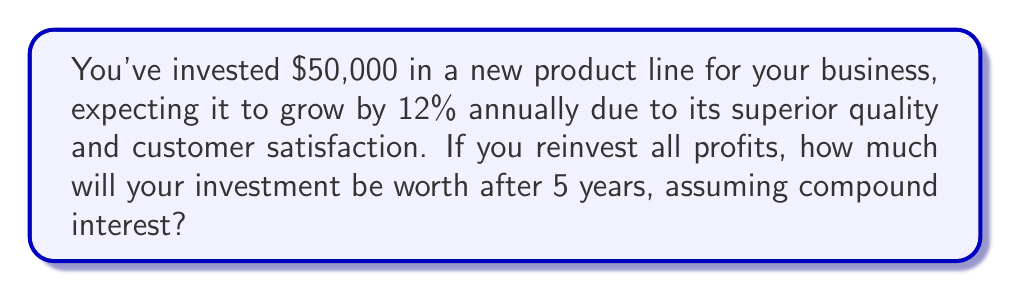Could you help me with this problem? To solve this problem, we'll use the compound interest formula:

$$ A = P(1 + r)^n $$

Where:
$A$ = Final amount
$P$ = Principal (initial investment)
$r$ = Annual interest rate (in decimal form)
$n$ = Number of years

Given:
$P = $50,000
$r = 12\% = 0.12
$n = 5$ years

Let's plug these values into the formula:

$$ A = 50,000(1 + 0.12)^5 $$

Now, let's calculate step-by-step:

1) First, calculate $(1 + 0.12)^5$:
   $$ (1.12)^5 = 1.762341968 $$

2) Multiply this result by the principal:
   $$ 50,000 \times 1.762341968 = 88,117.0984 $$

3) Round to the nearest cent:
   $$ 88,117.10 $$

Therefore, after 5 years, your $50,000 investment will grow to $88,117.10.
Answer: $88,117.10 